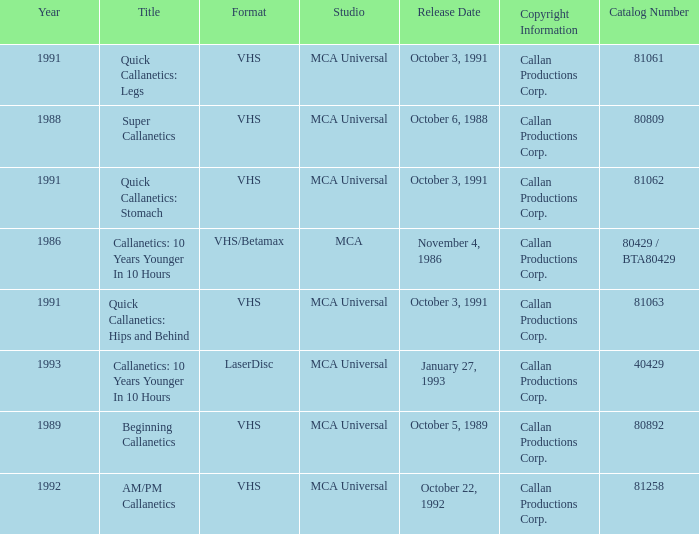Help me parse the entirety of this table. {'header': ['Year', 'Title', 'Format', 'Studio', 'Release Date', 'Copyright Information', 'Catalog Number'], 'rows': [['1991', 'Quick Callanetics: Legs', 'VHS', 'MCA Universal', 'October 3, 1991', 'Callan Productions Corp.', '81061'], ['1988', 'Super Callanetics', 'VHS', 'MCA Universal', 'October 6, 1988', 'Callan Productions Corp.', '80809'], ['1991', 'Quick Callanetics: Stomach', 'VHS', 'MCA Universal', 'October 3, 1991', 'Callan Productions Corp.', '81062'], ['1986', 'Callanetics: 10 Years Younger In 10 Hours', 'VHS/Betamax', 'MCA', 'November 4, 1986', 'Callan Productions Corp.', '80429 / BTA80429'], ['1991', 'Quick Callanetics: Hips and Behind', 'VHS', 'MCA Universal', 'October 3, 1991', 'Callan Productions Corp.', '81063'], ['1993', 'Callanetics: 10 Years Younger In 10 Hours', 'LaserDisc', 'MCA Universal', 'January 27, 1993', 'Callan Productions Corp.', '40429'], ['1989', 'Beginning Callanetics', 'VHS', 'MCA Universal', 'October 5, 1989', 'Callan Productions Corp.', '80892'], ['1992', 'AM/PM Callanetics', 'VHS', 'MCA Universal', 'October 22, 1992', 'Callan Productions Corp.', '81258']]} Name the catalog number for am/pm callanetics 81258.0. 